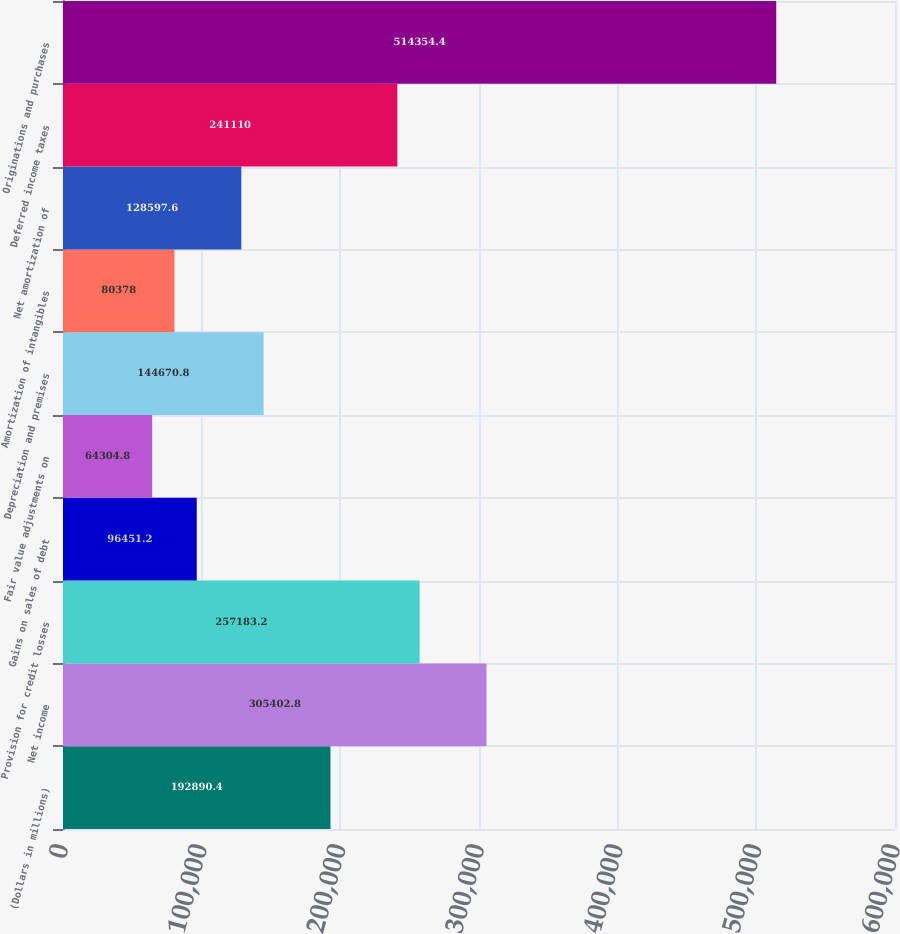<chart> <loc_0><loc_0><loc_500><loc_500><bar_chart><fcel>(Dollars in millions)<fcel>Net income<fcel>Provision for credit losses<fcel>Gains on sales of debt<fcel>Fair value adjustments on<fcel>Depreciation and premises<fcel>Amortization of intangibles<fcel>Net amortization of<fcel>Deferred income taxes<fcel>Originations and purchases<nl><fcel>192890<fcel>305403<fcel>257183<fcel>96451.2<fcel>64304.8<fcel>144671<fcel>80378<fcel>128598<fcel>241110<fcel>514354<nl></chart> 